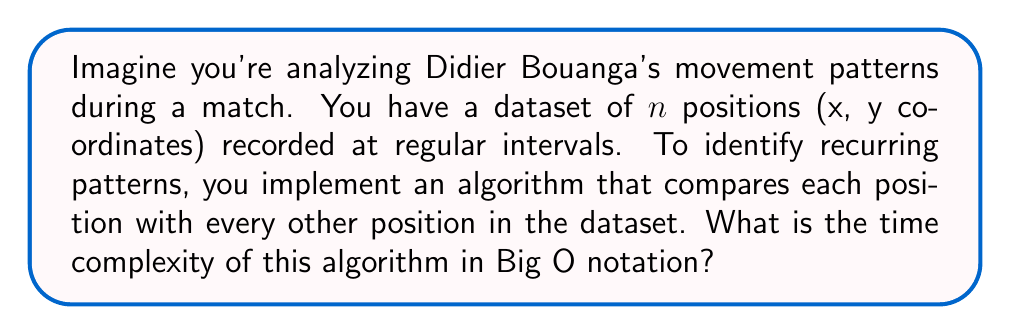Show me your answer to this math problem. Let's break this down step-by-step:

1) The algorithm compares each position with every other position. This means:
   - The first position is compared with $n-1$ other positions
   - The second position is compared with $n-2$ other positions
   - And so on...

2) This forms a series: $(n-1) + (n-2) + (n-3) + ... + 2 + 1$

3) This series is the sum of the first $(n-1)$ natural numbers, which has a well-known formula:

   $\sum_{i=1}^{n-1} i = \frac{n(n-1)}{2}$

4) Expanding this:

   $\frac{n^2 - n}{2}$

5) In Big O notation, we're concerned with the dominant term as $n$ grows large. Here, the dominant term is $n^2$.

6) The constant factor $\frac{1}{2}$ is ignored in Big O notation.

Therefore, the time complexity of this algorithm is $O(n^2)$.
Answer: $O(n^2)$ 